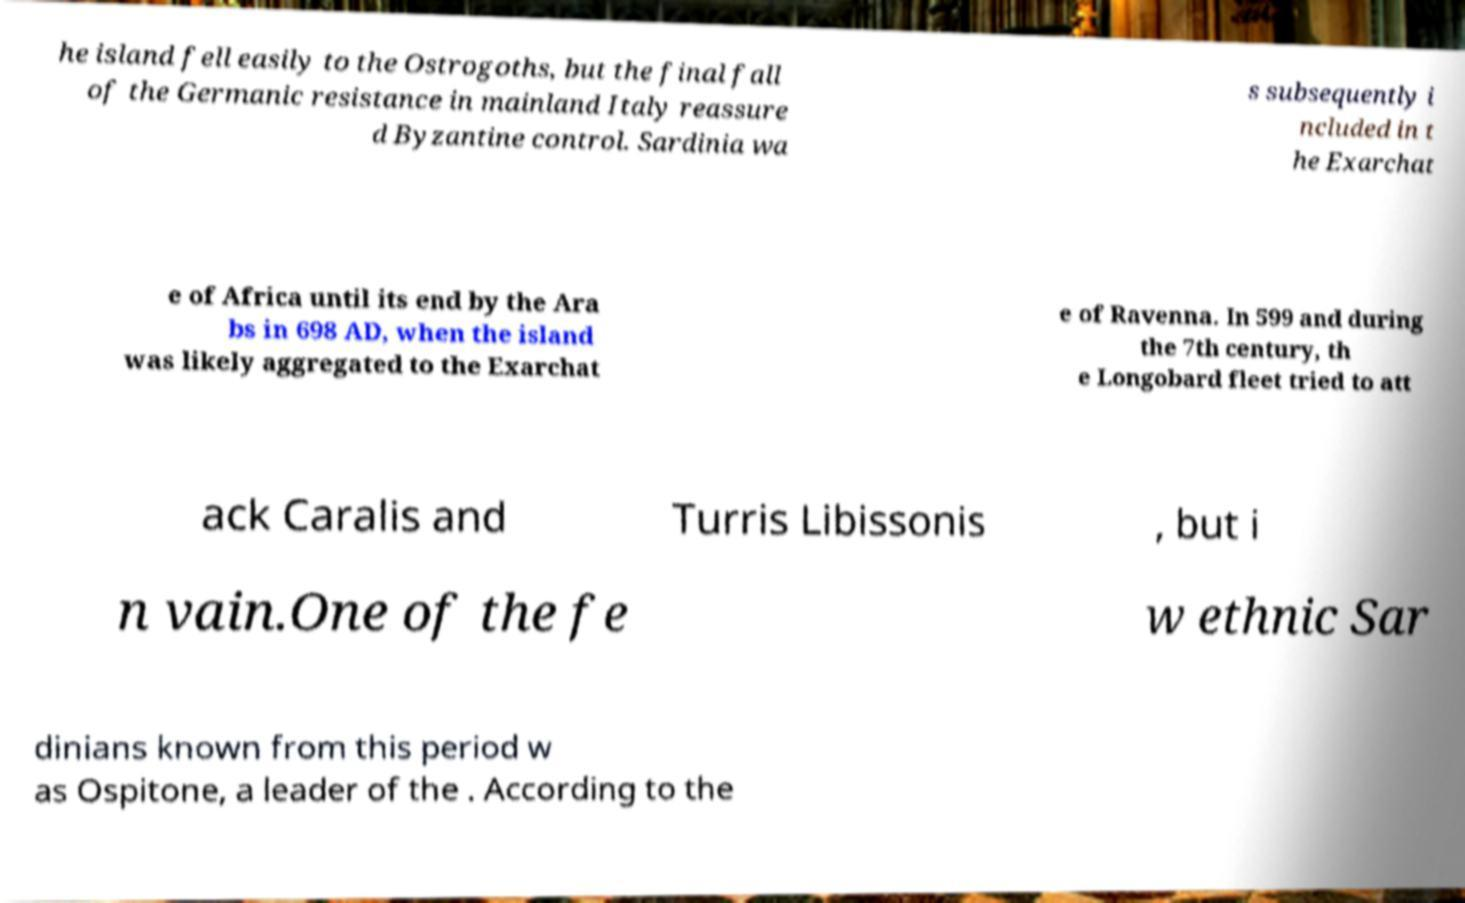For documentation purposes, I need the text within this image transcribed. Could you provide that? he island fell easily to the Ostrogoths, but the final fall of the Germanic resistance in mainland Italy reassure d Byzantine control. Sardinia wa s subsequently i ncluded in t he Exarchat e of Africa until its end by the Ara bs in 698 AD, when the island was likely aggregated to the Exarchat e of Ravenna. In 599 and during the 7th century, th e Longobard fleet tried to att ack Caralis and Turris Libissonis , but i n vain.One of the fe w ethnic Sar dinians known from this period w as Ospitone, a leader of the . According to the 